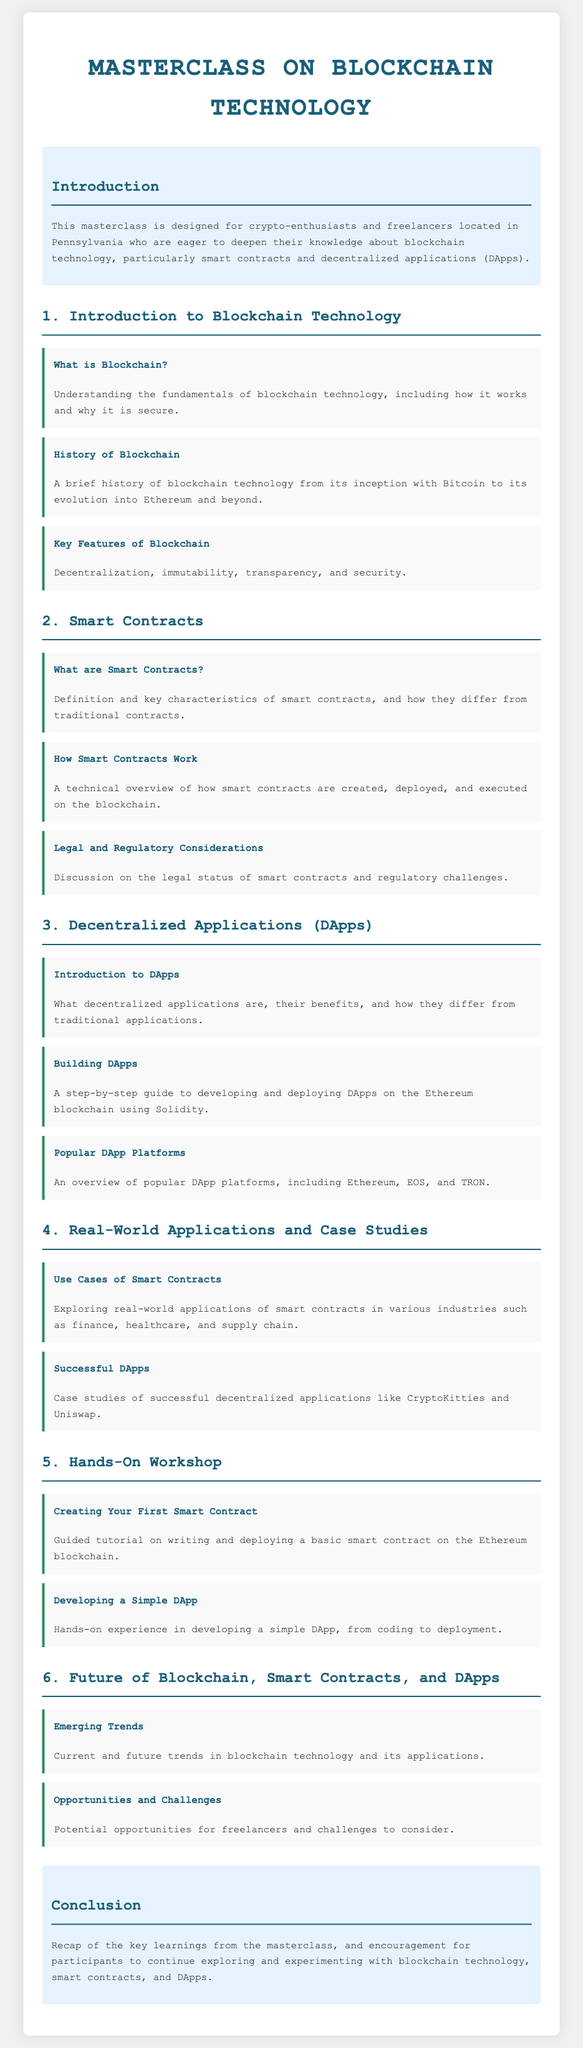What is the target audience of the masterclass? The target audience is specified in the introduction of the document as crypto-enthusiasts and freelancers located in Pennsylvania.
Answer: crypto-enthusiasts and freelancers located in Pennsylvania What is the first topic covered in the syllabus? The first topic listed in the document is "Introduction to Blockchain Technology."
Answer: Introduction to Blockchain Technology How many sections are there in the syllabus? The document outlines six main sections of the masterclass content.
Answer: six What technology is primarily used for building DApps mentioned in the syllabus? The syllabus specifies that Ethereum is the primary blockchain platform used for building DApps.
Answer: Ethereum What is the focus of the fifth section of the syllabus? The fifth section of the document focuses on hands-on workshops related to smart contracts and DApps.
Answer: Hands-On Workshop What kind of legal considerations are discussed in the context of smart contracts? The document highlights a section discussing the legal status and regulatory challenges surrounding smart contracts.
Answer: Legal and Regulatory Considerations Which successful DApp is provided as a case study in the syllabus? The document mentions CryptoKitties as one of the successful DApps for case study.
Answer: CryptoKitties What emerging trend is covered at the end of the syllabus? The final section discusses current and future trends in blockchain technology as an emerging theme.
Answer: Emerging Trends 